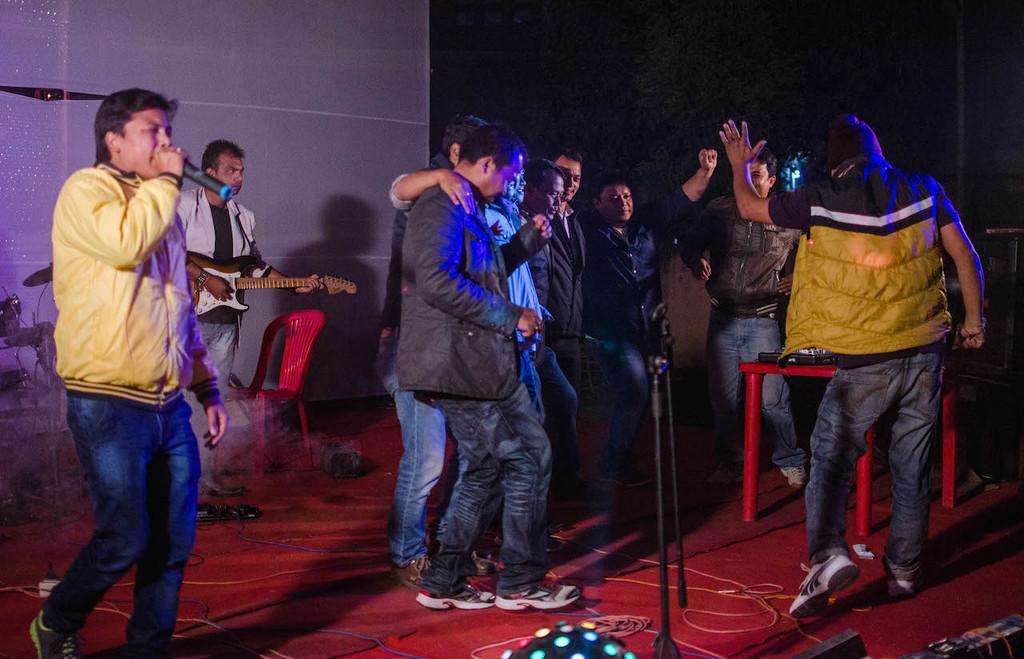How would you summarize this image in a sentence or two? This picture describes about group of people, on the left side of the image we can see a man, he is holding a microphone, beside to him we can find few musical instruments, a chair and a man, he is playing guitar, in front of them we can see microphones, cables and lights. 